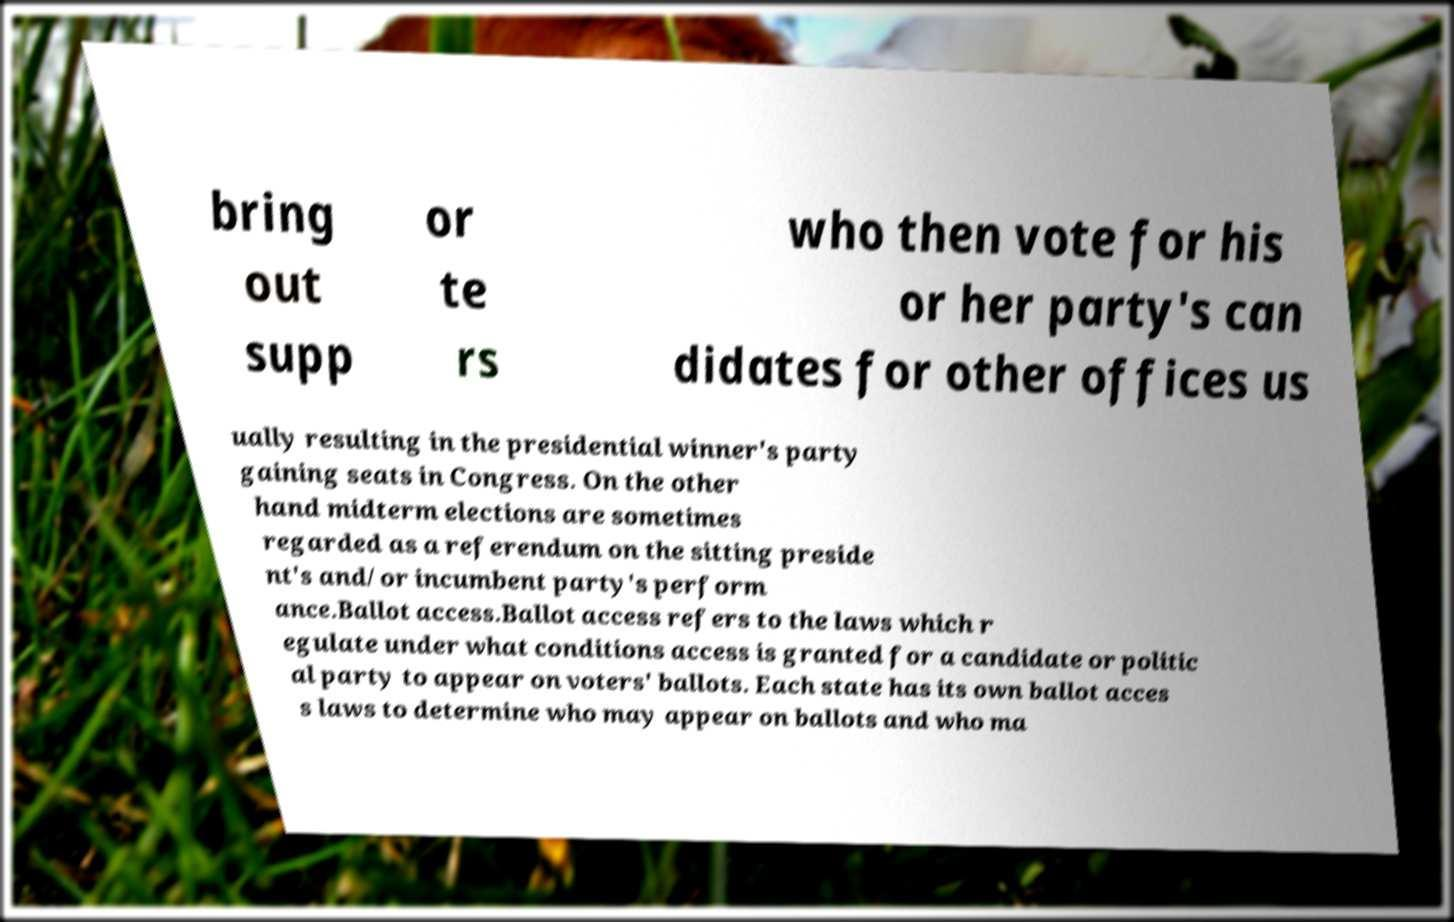Could you extract and type out the text from this image? bring out supp or te rs who then vote for his or her party's can didates for other offices us ually resulting in the presidential winner's party gaining seats in Congress. On the other hand midterm elections are sometimes regarded as a referendum on the sitting preside nt's and/or incumbent party's perform ance.Ballot access.Ballot access refers to the laws which r egulate under what conditions access is granted for a candidate or politic al party to appear on voters' ballots. Each state has its own ballot acces s laws to determine who may appear on ballots and who ma 